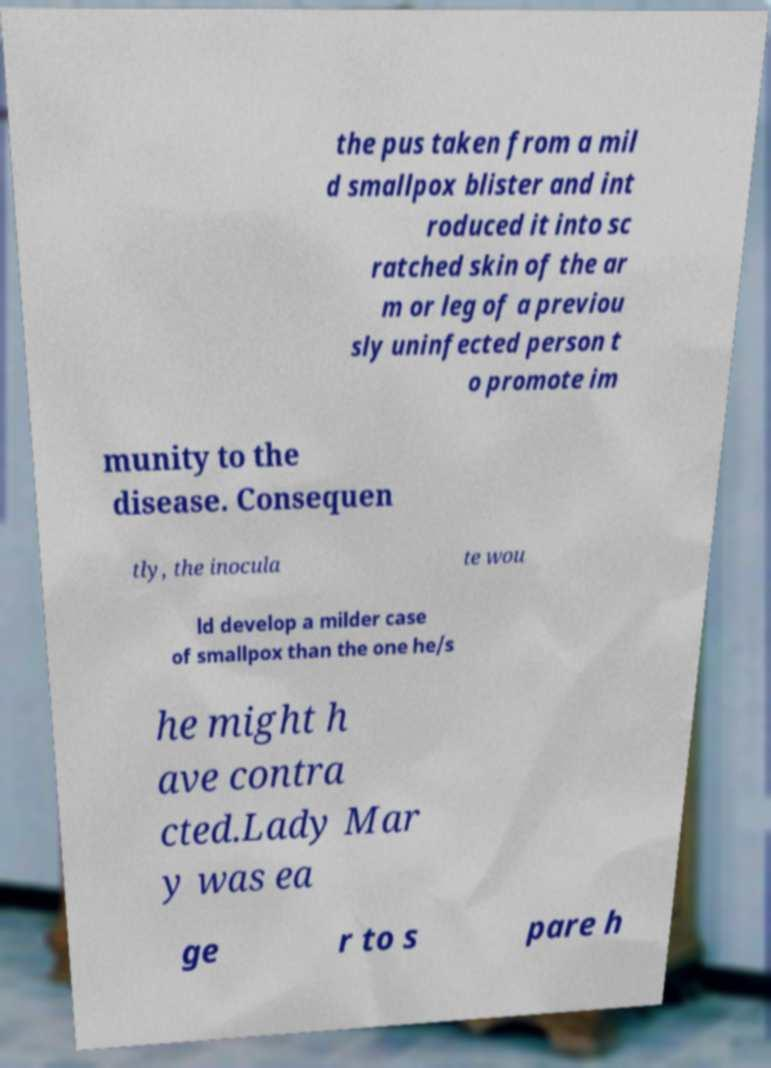Please identify and transcribe the text found in this image. the pus taken from a mil d smallpox blister and int roduced it into sc ratched skin of the ar m or leg of a previou sly uninfected person t o promote im munity to the disease. Consequen tly, the inocula te wou ld develop a milder case of smallpox than the one he/s he might h ave contra cted.Lady Mar y was ea ge r to s pare h 